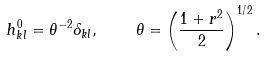Convert formula to latex. <formula><loc_0><loc_0><loc_500><loc_500>h ^ { 0 } _ { k l } = \theta ^ { - 2 } \delta _ { k l } , \quad \theta = \left ( \frac { 1 + r ^ { 2 } } { 2 } \right ) ^ { 1 / 2 } .</formula> 